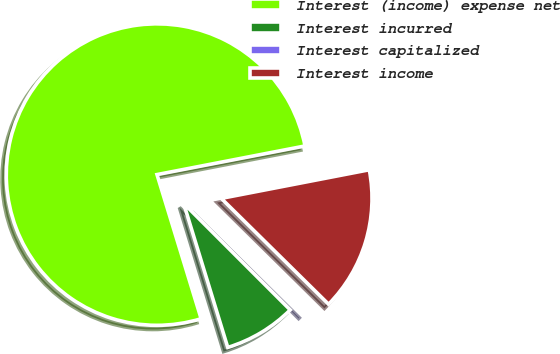<chart> <loc_0><loc_0><loc_500><loc_500><pie_chart><fcel>Interest (income) expense net<fcel>Interest incurred<fcel>Interest capitalized<fcel>Interest income<nl><fcel>76.69%<fcel>7.77%<fcel>0.11%<fcel>15.43%<nl></chart> 